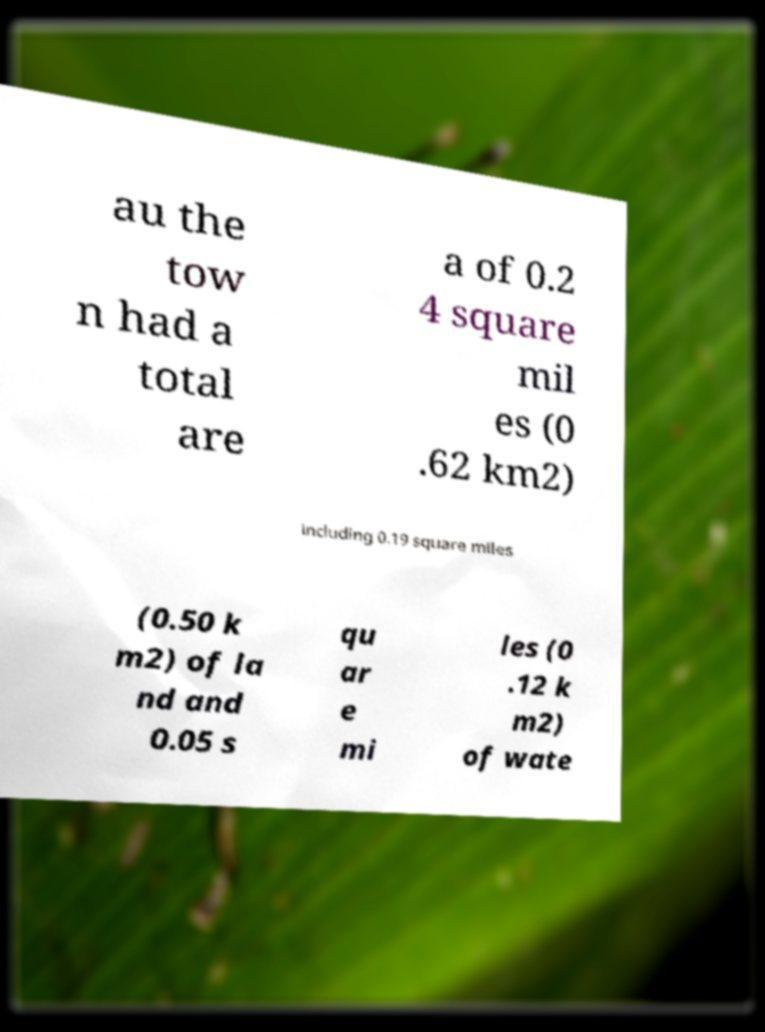Please identify and transcribe the text found in this image. au the tow n had a total are a of 0.2 4 square mil es (0 .62 km2) including 0.19 square miles (0.50 k m2) of la nd and 0.05 s qu ar e mi les (0 .12 k m2) of wate 